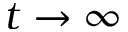<formula> <loc_0><loc_0><loc_500><loc_500>t \rightarrow \infty</formula> 